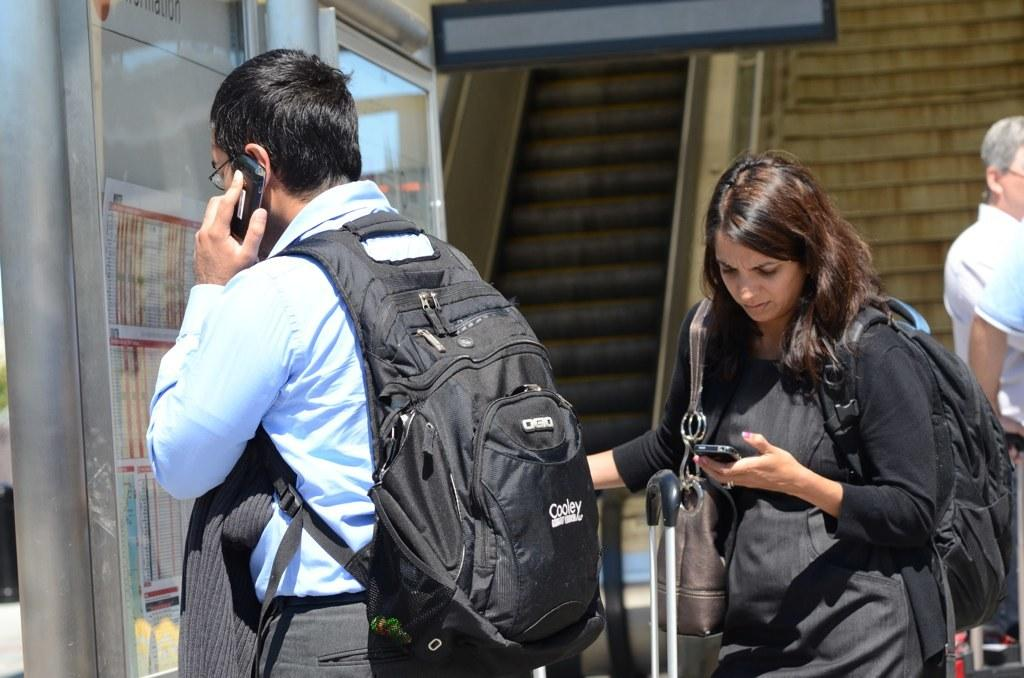<image>
Relay a brief, clear account of the picture shown. A man with a Cooley backpack is talking on his cell phone. 